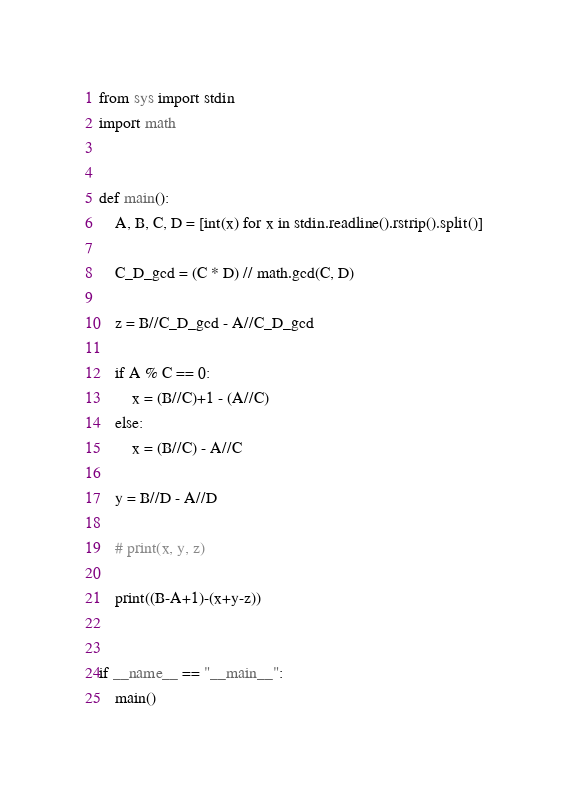Convert code to text. <code><loc_0><loc_0><loc_500><loc_500><_Python_>from sys import stdin
import math


def main():
    A, B, C, D = [int(x) for x in stdin.readline().rstrip().split()]

    C_D_gcd = (C * D) // math.gcd(C, D)

    z = B//C_D_gcd - A//C_D_gcd

    if A % C == 0:
        x = (B//C)+1 - (A//C)
    else:
        x = (B//C) - A//C

    y = B//D - A//D

    # print(x, y, z)

    print((B-A+1)-(x+y-z))


if __name__ == "__main__":
    main()
</code> 